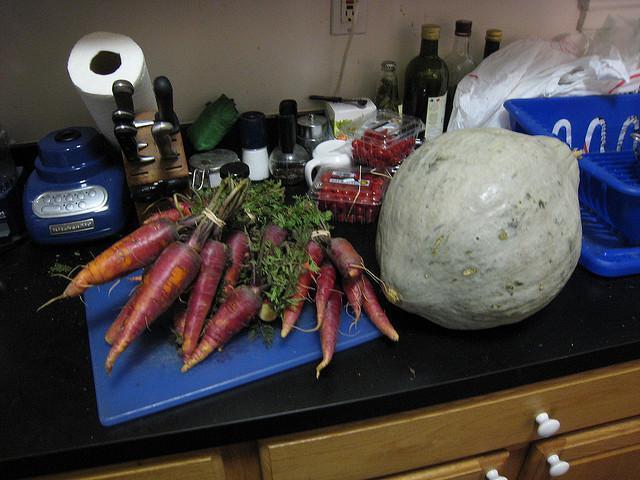How many handles are in the picture?
Give a very brief answer. 3. How many carrots can be seen?
Give a very brief answer. 4. How many zebras are in the road?
Give a very brief answer. 0. 